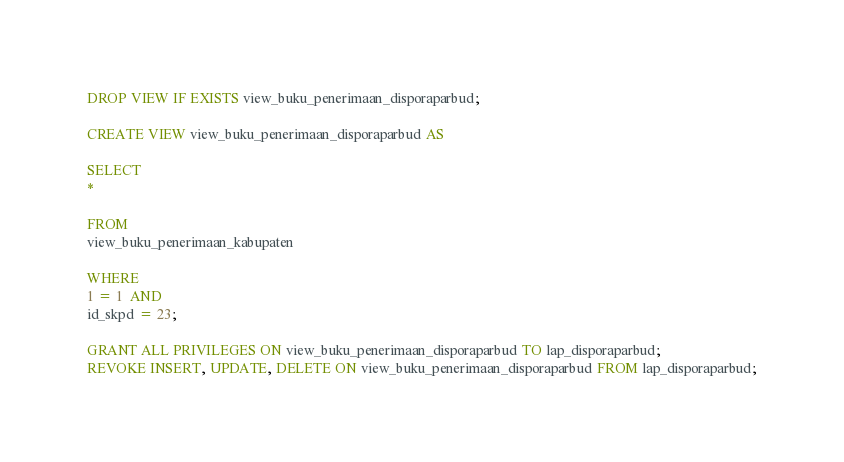Convert code to text. <code><loc_0><loc_0><loc_500><loc_500><_SQL_>DROP VIEW IF EXISTS view_buku_penerimaan_disporaparbud;

CREATE VIEW view_buku_penerimaan_disporaparbud AS

SELECT
*

FROM
view_buku_penerimaan_kabupaten

WHERE
1 = 1  AND
id_skpd = 23;

GRANT ALL PRIVILEGES ON view_buku_penerimaan_disporaparbud TO lap_disporaparbud;
REVOKE INSERT, UPDATE, DELETE ON view_buku_penerimaan_disporaparbud FROM lap_disporaparbud;
</code> 